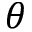Convert formula to latex. <formula><loc_0><loc_0><loc_500><loc_500>\theta</formula> 